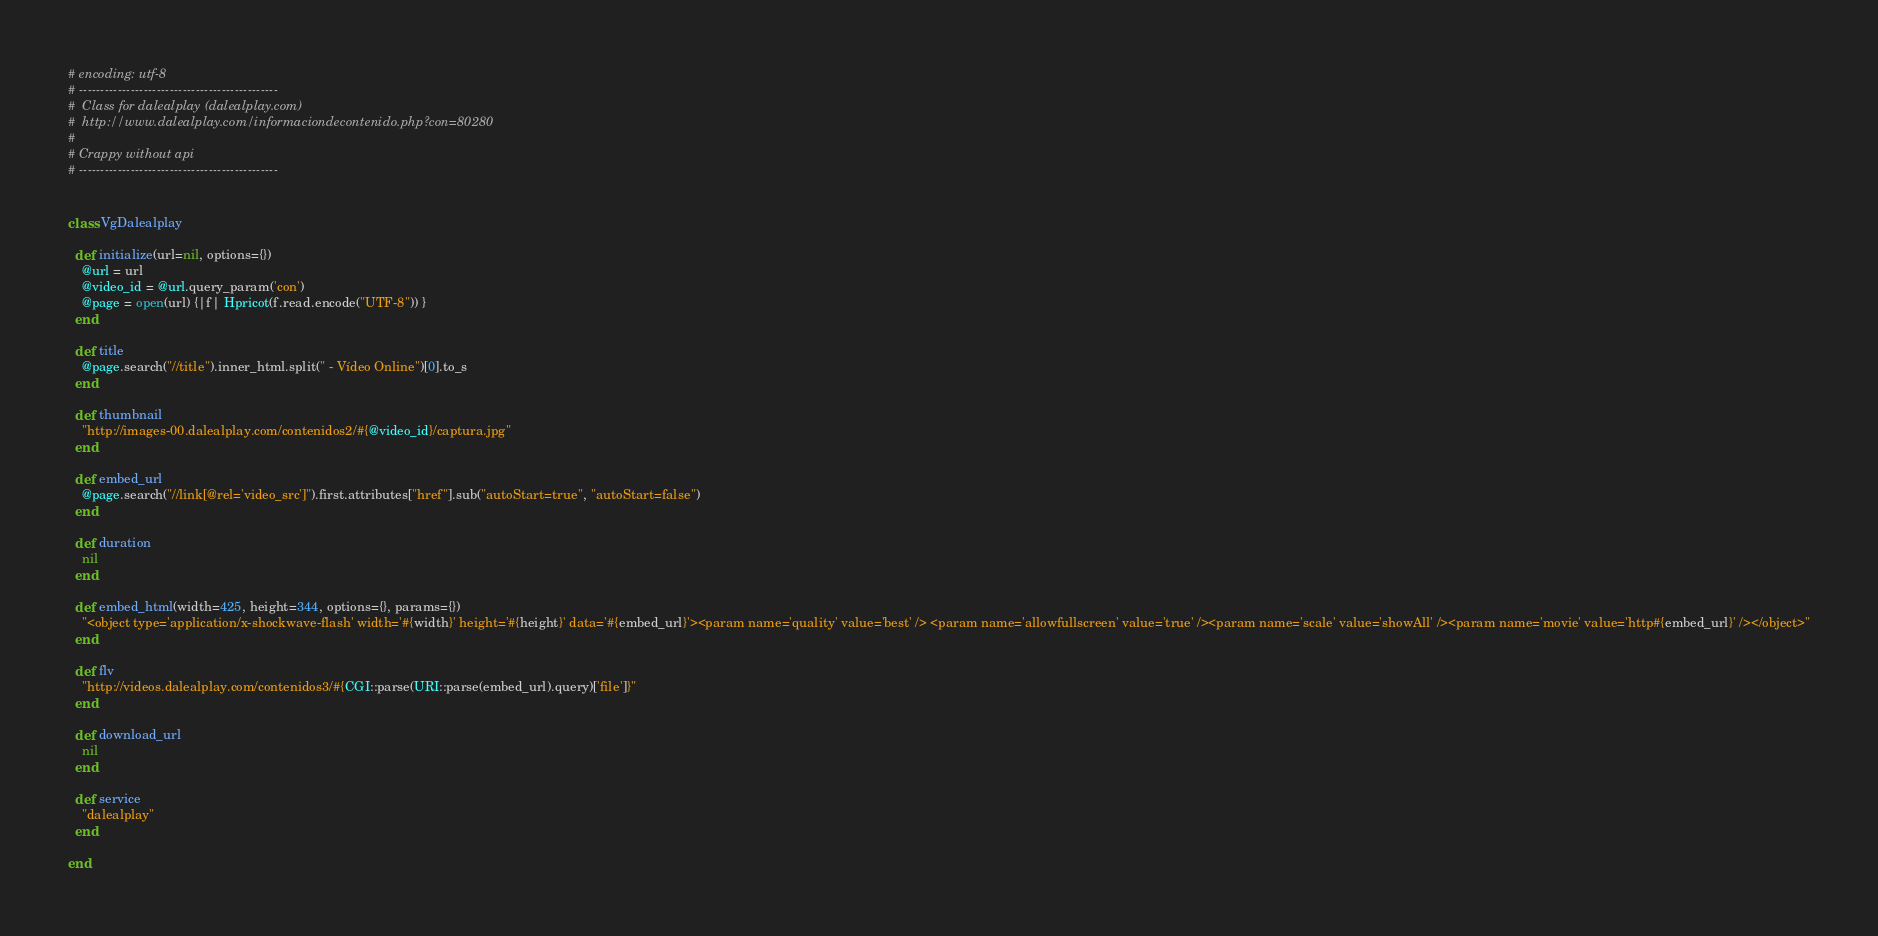Convert code to text. <code><loc_0><loc_0><loc_500><loc_500><_Ruby_># encoding: utf-8
# ----------------------------------------------
#  Class for dalealplay (dalealplay.com)
#  http://www.dalealplay.com/informaciondecontenido.php?con=80280
# 
# Crappy without api
# ----------------------------------------------


class VgDalealplay
  
  def initialize(url=nil, options={})
    @url = url
    @video_id = @url.query_param('con')
    @page = open(url) {|f| Hpricot(f.read.encode("UTF-8")) }
  end
  
  def title
    @page.search("//title").inner_html.split(" - Vídeo Online")[0].to_s
  end
  
  def thumbnail
    "http://images-00.dalealplay.com/contenidos2/#{@video_id}/captura.jpg"
  end
  
  def embed_url
    @page.search("//link[@rel='video_src']").first.attributes["href"].sub("autoStart=true", "autoStart=false")
  end

  def duration
    nil
  end

  def embed_html(width=425, height=344, options={}, params={})
    "<object type='application/x-shockwave-flash' width='#{width}' height='#{height}' data='#{embed_url}'><param name='quality' value='best' />	<param name='allowfullscreen' value='true' /><param name='scale' value='showAll' /><param name='movie' value='http#{embed_url}' /></object>"
  end
  
  def flv
    "http://videos.dalealplay.com/contenidos3/#{CGI::parse(URI::parse(embed_url).query)['file']}"
  end

  def download_url
    nil
  end

  def service
    "dalealplay"
  end
  
end</code> 